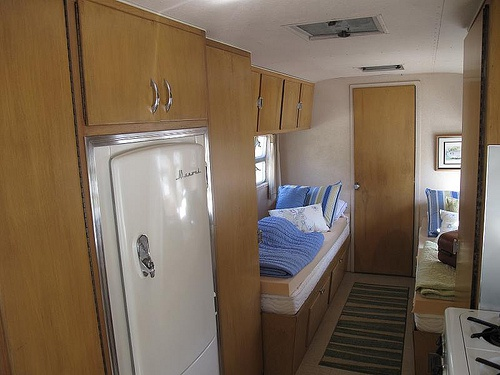Describe the objects in this image and their specific colors. I can see refrigerator in maroon, darkgray, lightgray, and gray tones, bed in maroon, black, gray, and darkgray tones, bed in maroon, gray, and darkgray tones, oven in maroon, gray, and black tones, and suitcase in maroon, black, and gray tones in this image. 